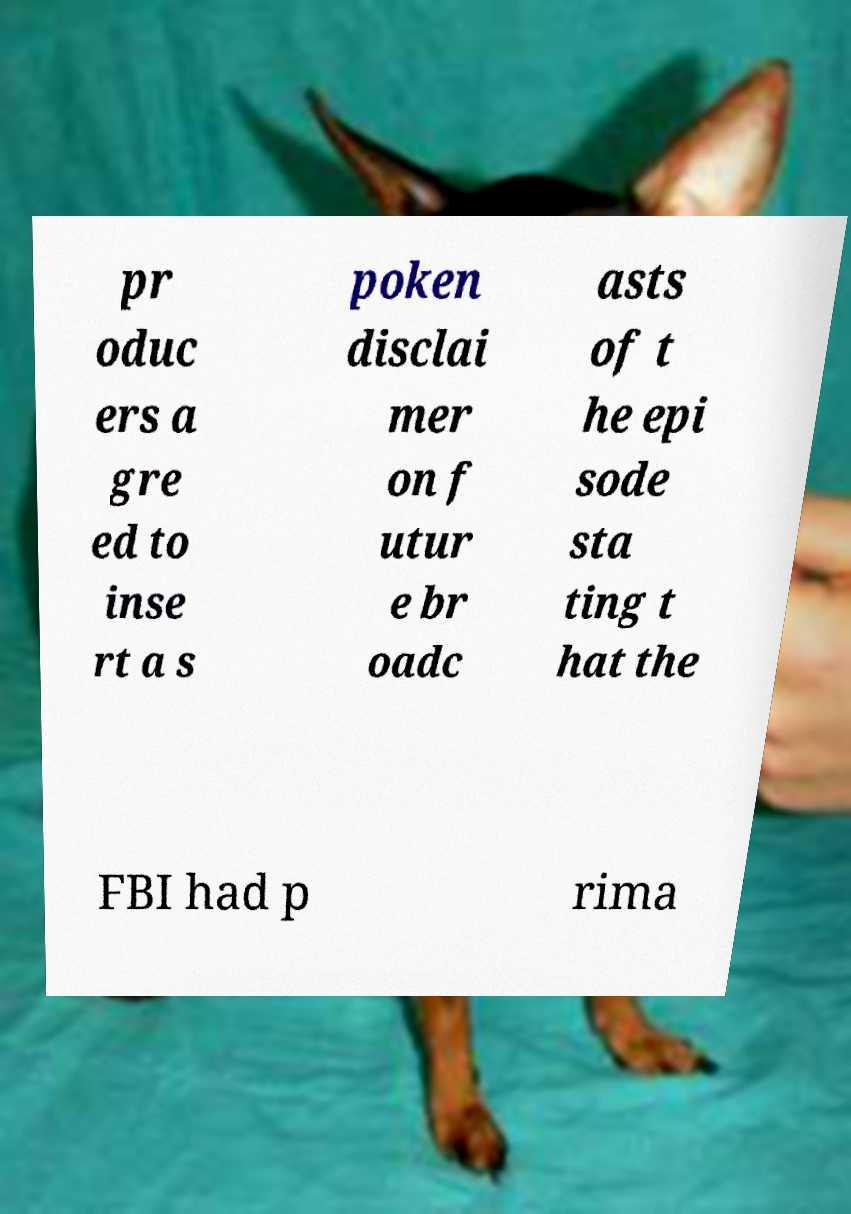Could you extract and type out the text from this image? pr oduc ers a gre ed to inse rt a s poken disclai mer on f utur e br oadc asts of t he epi sode sta ting t hat the FBI had p rima 